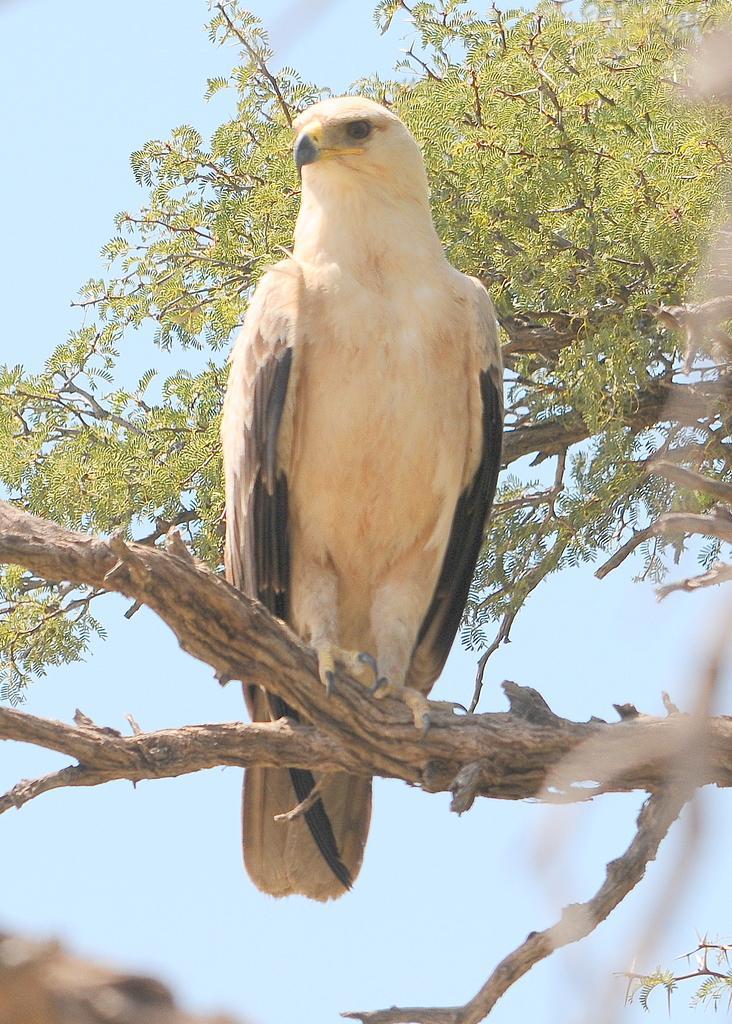Please provide a concise description of this image. In this image there is a bird visible on trunk of tree, there is a tree, the sky in the middle. 